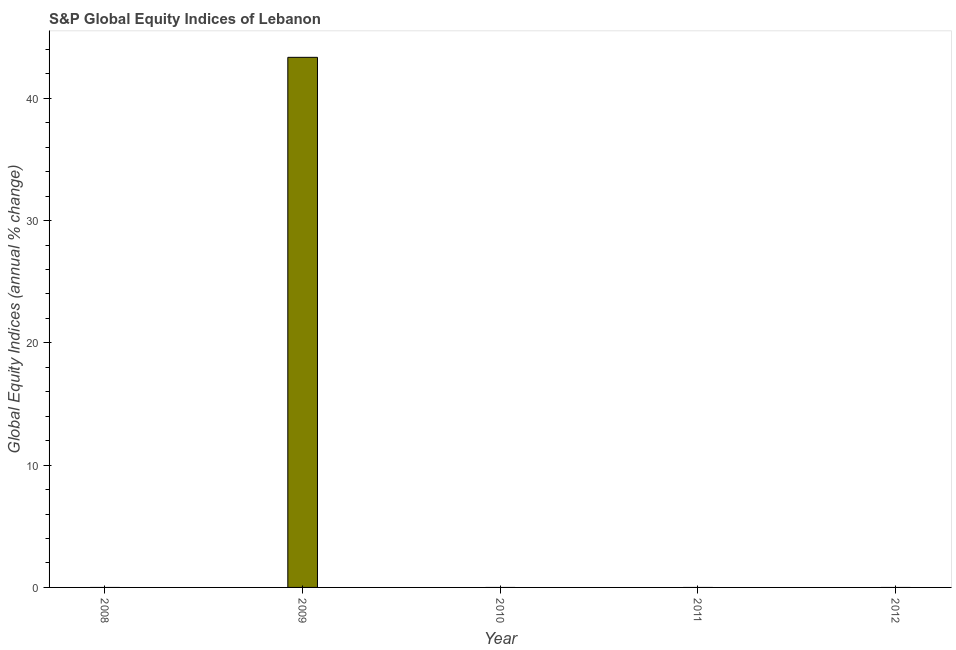Does the graph contain grids?
Keep it short and to the point. No. What is the title of the graph?
Give a very brief answer. S&P Global Equity Indices of Lebanon. What is the label or title of the X-axis?
Provide a succinct answer. Year. What is the label or title of the Y-axis?
Offer a terse response. Global Equity Indices (annual % change). What is the s&p global equity indices in 2008?
Give a very brief answer. 0. Across all years, what is the maximum s&p global equity indices?
Keep it short and to the point. 43.36. What is the sum of the s&p global equity indices?
Your answer should be compact. 43.36. What is the average s&p global equity indices per year?
Offer a terse response. 8.67. What is the median s&p global equity indices?
Give a very brief answer. 0. What is the difference between the highest and the lowest s&p global equity indices?
Offer a terse response. 43.36. How many bars are there?
Keep it short and to the point. 1. Are all the bars in the graph horizontal?
Give a very brief answer. No. What is the difference between two consecutive major ticks on the Y-axis?
Your answer should be very brief. 10. Are the values on the major ticks of Y-axis written in scientific E-notation?
Offer a terse response. No. What is the Global Equity Indices (annual % change) in 2009?
Ensure brevity in your answer.  43.36. What is the Global Equity Indices (annual % change) of 2010?
Make the answer very short. 0. What is the Global Equity Indices (annual % change) of 2012?
Offer a terse response. 0. 